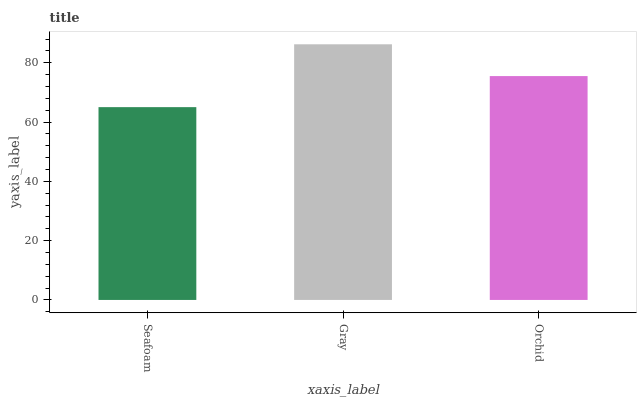Is Seafoam the minimum?
Answer yes or no. Yes. Is Gray the maximum?
Answer yes or no. Yes. Is Orchid the minimum?
Answer yes or no. No. Is Orchid the maximum?
Answer yes or no. No. Is Gray greater than Orchid?
Answer yes or no. Yes. Is Orchid less than Gray?
Answer yes or no. Yes. Is Orchid greater than Gray?
Answer yes or no. No. Is Gray less than Orchid?
Answer yes or no. No. Is Orchid the high median?
Answer yes or no. Yes. Is Orchid the low median?
Answer yes or no. Yes. Is Gray the high median?
Answer yes or no. No. Is Seafoam the low median?
Answer yes or no. No. 